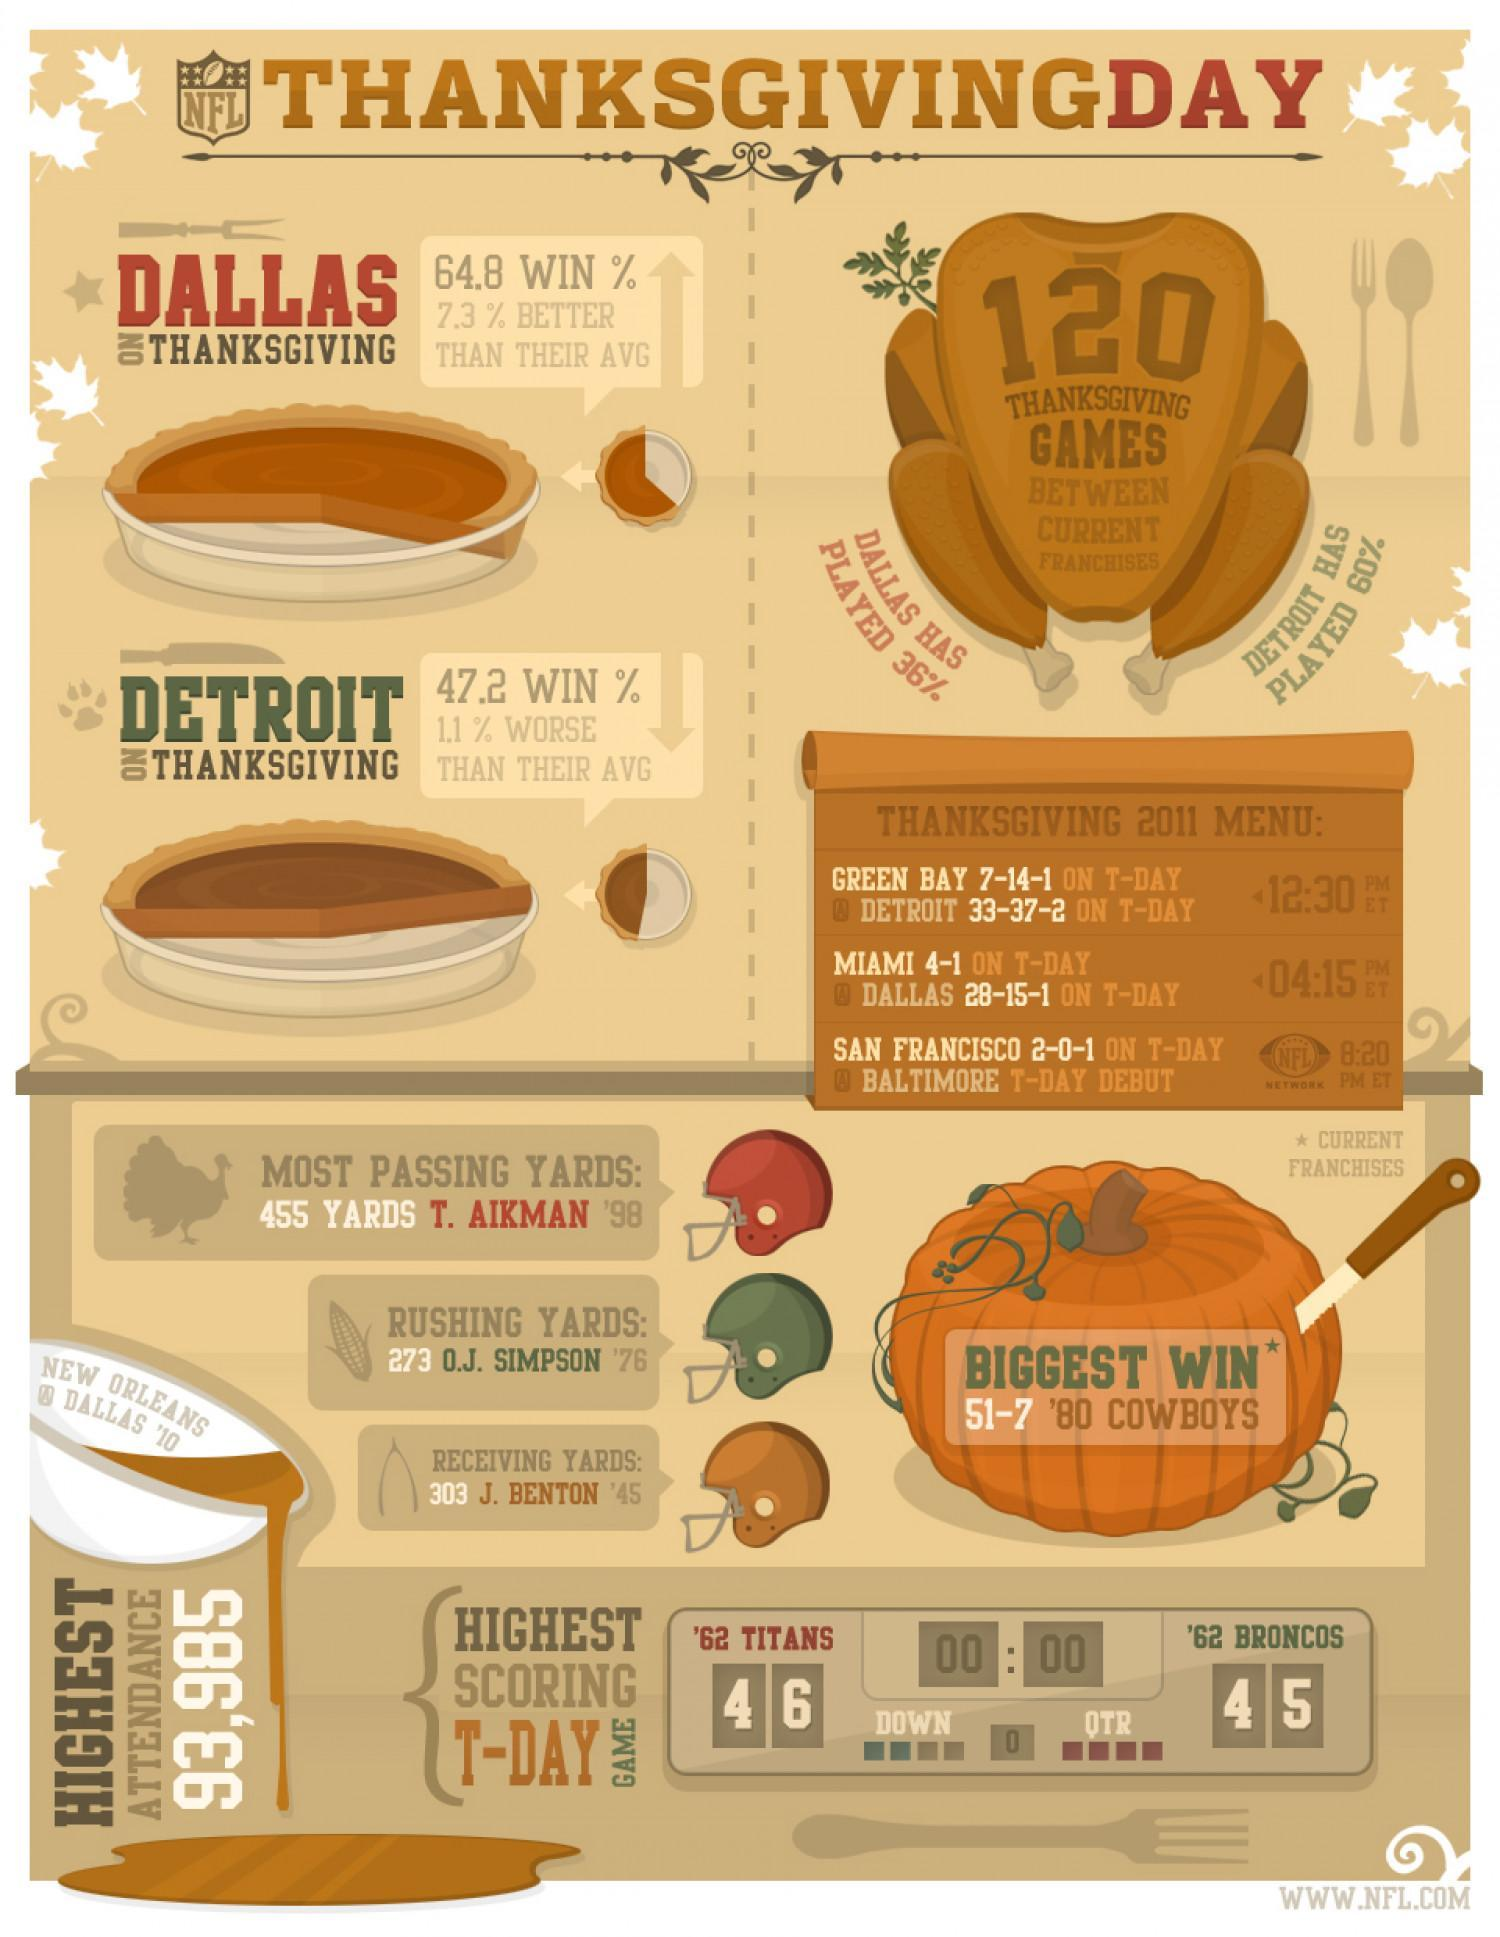Who has better chances of winning the game on Thanksgiving, Dallas or Detroit?
Answer the question with a short phrase. Dallas How much percentage of games has Detroit played more than Dallas? 24% 